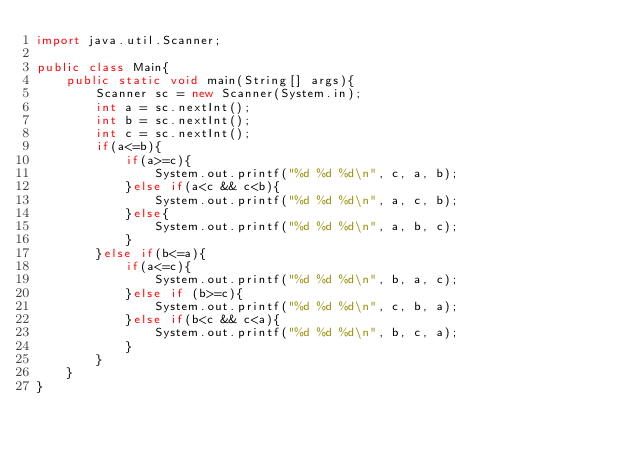<code> <loc_0><loc_0><loc_500><loc_500><_Java_>import java.util.Scanner;

public class Main{
	public static void main(String[] args){
		Scanner sc = new Scanner(System.in);
		int a = sc.nextInt();
		int b = sc.nextInt();
		int c = sc.nextInt();
		if(a<=b){
			if(a>=c){
				System.out.printf("%d %d %d\n", c, a, b);
			}else if(a<c && c<b){
				System.out.printf("%d %d %d\n", a, c, b);
			}else{
				System.out.printf("%d %d %d\n", a, b, c);
			}
		}else if(b<=a){
			if(a<=c){
				System.out.printf("%d %d %d\n", b, a, c);
			}else if (b>=c){
				System.out.printf("%d %d %d\n", c, b, a);
			}else if(b<c && c<a){
				System.out.printf("%d %d %d\n", b, c, a);
			} 
		}
	}
}
			
			</code> 